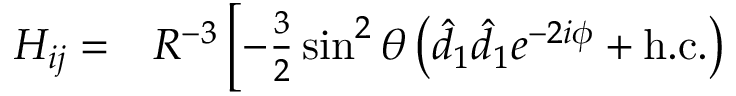<formula> <loc_0><loc_0><loc_500><loc_500>\begin{array} { r l } { H _ { i j } = } & R ^ { - 3 } \left [ - \frac { 3 } { 2 } \sin ^ { 2 } \theta \left ( \hat { d } _ { 1 } \hat { d } _ { 1 } e ^ { - 2 i \phi } + { h . c . } \right ) } \end{array}</formula> 